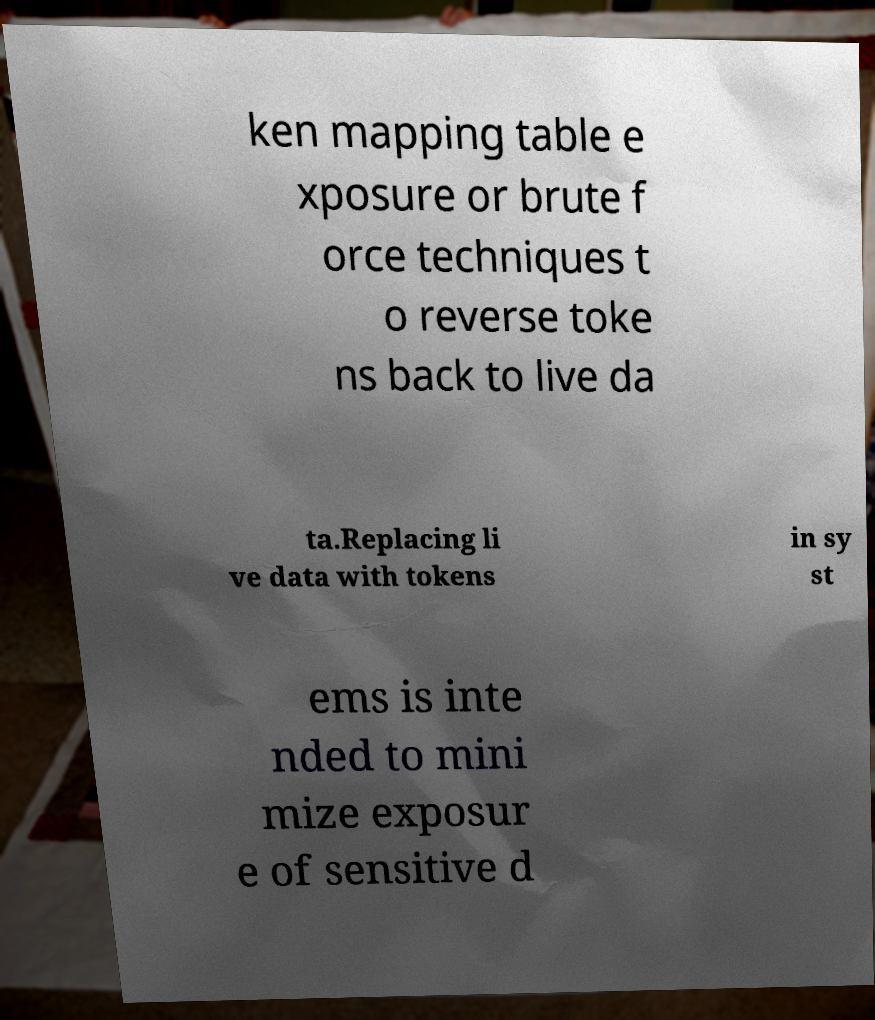Please identify and transcribe the text found in this image. ken mapping table e xposure or brute f orce techniques t o reverse toke ns back to live da ta.Replacing li ve data with tokens in sy st ems is inte nded to mini mize exposur e of sensitive d 